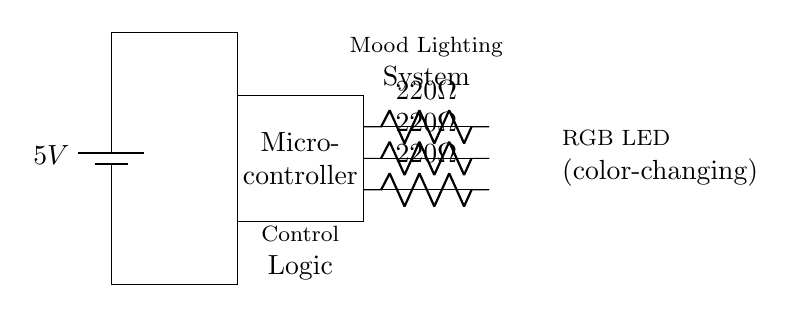What is the type of power supply used in this circuit? The circuit uses a battery as a power supply, indicated by the battery symbol at the top of the diagram.
Answer: Battery What is the purpose of the resistors in this circuit? The resistors limit the current flowing to the RGB LED, which helps prevent damage from excessive current.
Answer: Current limiting What is the role of the microcontroller? The microcontroller controls the RGB LED's color and behavior based on a programmed logic for mood lighting.
Answer: Control logic How many resistors are present in the circuit? There are three resistors connected in series to the RGB LED; each corresponds to one color channel.
Answer: Three What voltage does the circuit operate at? The circuit is powered by a 5V battery, as shown next to the battery symbol in the diagram.
Answer: Five volts What type of LED is used in this circuit? An RGB LED is used, which has color-changing capabilities as indicated in the labels next to the LED.
Answer: RGB LED What is the value of each resistor used in this circuit? Each resistor in the circuit is labeled as 220 Ohms, which is noted next to each resistor symbol.
Answer: Two hundred twenty Ohms 